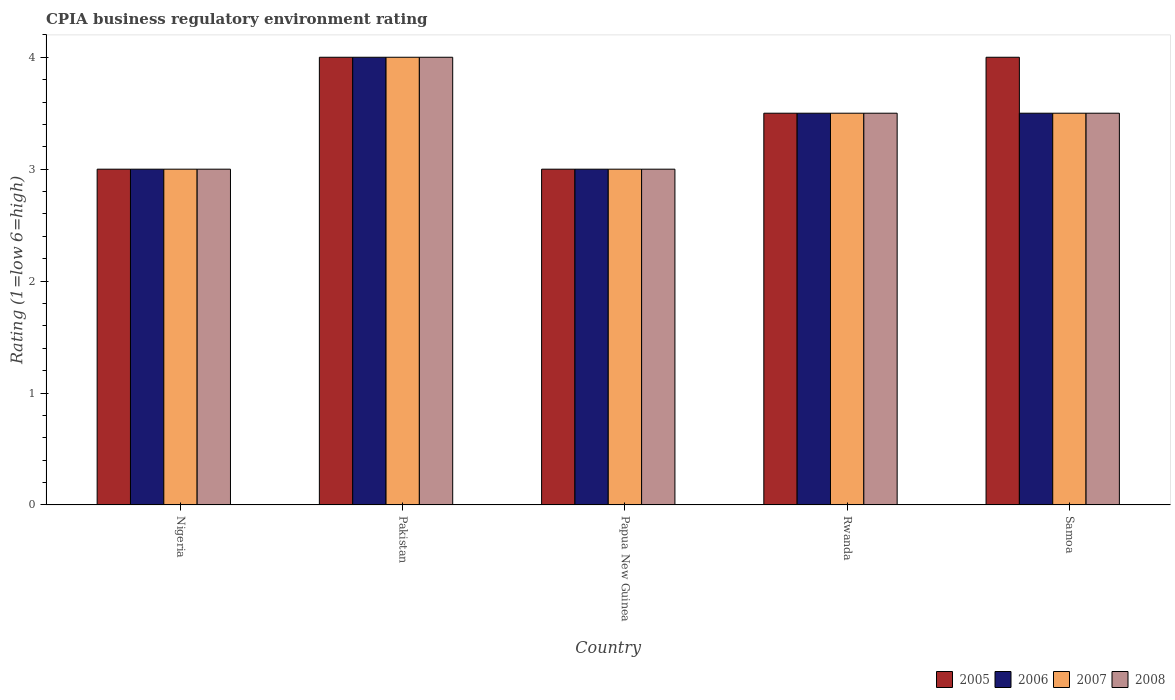How many groups of bars are there?
Keep it short and to the point. 5. Are the number of bars on each tick of the X-axis equal?
Offer a terse response. Yes. What is the label of the 4th group of bars from the left?
Your response must be concise. Rwanda. In how many cases, is the number of bars for a given country not equal to the number of legend labels?
Give a very brief answer. 0. What is the CPIA rating in 2007 in Nigeria?
Give a very brief answer. 3. Across all countries, what is the maximum CPIA rating in 2008?
Your answer should be very brief. 4. In which country was the CPIA rating in 2008 maximum?
Your answer should be very brief. Pakistan. In which country was the CPIA rating in 2008 minimum?
Make the answer very short. Nigeria. What is the total CPIA rating in 2008 in the graph?
Your response must be concise. 17. What is the difference between the CPIA rating in 2006 in Rwanda and the CPIA rating in 2008 in Papua New Guinea?
Offer a very short reply. 0.5. What is the average CPIA rating in 2005 per country?
Provide a succinct answer. 3.5. In how many countries, is the CPIA rating in 2008 greater than 1?
Your answer should be compact. 5. What is the ratio of the CPIA rating in 2008 in Papua New Guinea to that in Rwanda?
Your response must be concise. 0.86. In how many countries, is the CPIA rating in 2007 greater than the average CPIA rating in 2007 taken over all countries?
Provide a short and direct response. 3. What does the 3rd bar from the left in Samoa represents?
Provide a succinct answer. 2007. What does the 1st bar from the right in Rwanda represents?
Make the answer very short. 2008. How many bars are there?
Ensure brevity in your answer.  20. Are all the bars in the graph horizontal?
Give a very brief answer. No. Are the values on the major ticks of Y-axis written in scientific E-notation?
Offer a terse response. No. Does the graph contain any zero values?
Give a very brief answer. No. Does the graph contain grids?
Make the answer very short. No. What is the title of the graph?
Your answer should be very brief. CPIA business regulatory environment rating. Does "1988" appear as one of the legend labels in the graph?
Your answer should be very brief. No. What is the Rating (1=low 6=high) in 2006 in Nigeria?
Offer a terse response. 3. What is the Rating (1=low 6=high) in 2008 in Nigeria?
Give a very brief answer. 3. What is the Rating (1=low 6=high) in 2006 in Pakistan?
Your answer should be very brief. 4. What is the Rating (1=low 6=high) of 2007 in Pakistan?
Keep it short and to the point. 4. What is the Rating (1=low 6=high) of 2005 in Papua New Guinea?
Keep it short and to the point. 3. What is the Rating (1=low 6=high) in 2005 in Rwanda?
Your response must be concise. 3.5. What is the Rating (1=low 6=high) in 2007 in Rwanda?
Your answer should be compact. 3.5. What is the Rating (1=low 6=high) in 2008 in Rwanda?
Make the answer very short. 3.5. What is the Rating (1=low 6=high) in 2005 in Samoa?
Your answer should be compact. 4. What is the Rating (1=low 6=high) in 2008 in Samoa?
Offer a very short reply. 3.5. Across all countries, what is the maximum Rating (1=low 6=high) of 2005?
Offer a terse response. 4. Across all countries, what is the minimum Rating (1=low 6=high) in 2005?
Provide a short and direct response. 3. Across all countries, what is the minimum Rating (1=low 6=high) of 2006?
Give a very brief answer. 3. Across all countries, what is the minimum Rating (1=low 6=high) of 2008?
Keep it short and to the point. 3. What is the total Rating (1=low 6=high) of 2005 in the graph?
Your response must be concise. 17.5. What is the difference between the Rating (1=low 6=high) of 2007 in Nigeria and that in Pakistan?
Your response must be concise. -1. What is the difference between the Rating (1=low 6=high) in 2008 in Nigeria and that in Pakistan?
Keep it short and to the point. -1. What is the difference between the Rating (1=low 6=high) in 2006 in Nigeria and that in Papua New Guinea?
Provide a short and direct response. 0. What is the difference between the Rating (1=low 6=high) in 2007 in Nigeria and that in Papua New Guinea?
Your response must be concise. 0. What is the difference between the Rating (1=low 6=high) of 2005 in Nigeria and that in Rwanda?
Your answer should be compact. -0.5. What is the difference between the Rating (1=low 6=high) in 2007 in Nigeria and that in Rwanda?
Give a very brief answer. -0.5. What is the difference between the Rating (1=low 6=high) in 2008 in Nigeria and that in Rwanda?
Ensure brevity in your answer.  -0.5. What is the difference between the Rating (1=low 6=high) in 2005 in Nigeria and that in Samoa?
Your answer should be very brief. -1. What is the difference between the Rating (1=low 6=high) of 2007 in Nigeria and that in Samoa?
Provide a short and direct response. -0.5. What is the difference between the Rating (1=low 6=high) of 2008 in Nigeria and that in Samoa?
Your answer should be very brief. -0.5. What is the difference between the Rating (1=low 6=high) of 2005 in Pakistan and that in Papua New Guinea?
Your response must be concise. 1. What is the difference between the Rating (1=low 6=high) of 2006 in Pakistan and that in Papua New Guinea?
Offer a terse response. 1. What is the difference between the Rating (1=low 6=high) in 2008 in Pakistan and that in Papua New Guinea?
Provide a short and direct response. 1. What is the difference between the Rating (1=low 6=high) of 2006 in Pakistan and that in Rwanda?
Your answer should be very brief. 0.5. What is the difference between the Rating (1=low 6=high) of 2007 in Pakistan and that in Rwanda?
Give a very brief answer. 0.5. What is the difference between the Rating (1=low 6=high) in 2006 in Pakistan and that in Samoa?
Keep it short and to the point. 0.5. What is the difference between the Rating (1=low 6=high) in 2008 in Pakistan and that in Samoa?
Ensure brevity in your answer.  0.5. What is the difference between the Rating (1=low 6=high) in 2005 in Papua New Guinea and that in Rwanda?
Your answer should be very brief. -0.5. What is the difference between the Rating (1=low 6=high) of 2006 in Papua New Guinea and that in Rwanda?
Provide a short and direct response. -0.5. What is the difference between the Rating (1=low 6=high) of 2007 in Papua New Guinea and that in Rwanda?
Provide a short and direct response. -0.5. What is the difference between the Rating (1=low 6=high) in 2005 in Papua New Guinea and that in Samoa?
Provide a succinct answer. -1. What is the difference between the Rating (1=low 6=high) in 2008 in Papua New Guinea and that in Samoa?
Ensure brevity in your answer.  -0.5. What is the difference between the Rating (1=low 6=high) of 2006 in Rwanda and that in Samoa?
Offer a very short reply. 0. What is the difference between the Rating (1=low 6=high) in 2007 in Rwanda and that in Samoa?
Make the answer very short. 0. What is the difference between the Rating (1=low 6=high) in 2008 in Rwanda and that in Samoa?
Your answer should be very brief. 0. What is the difference between the Rating (1=low 6=high) in 2005 in Nigeria and the Rating (1=low 6=high) in 2006 in Pakistan?
Offer a terse response. -1. What is the difference between the Rating (1=low 6=high) of 2005 in Nigeria and the Rating (1=low 6=high) of 2007 in Pakistan?
Your answer should be very brief. -1. What is the difference between the Rating (1=low 6=high) of 2005 in Nigeria and the Rating (1=low 6=high) of 2008 in Pakistan?
Provide a short and direct response. -1. What is the difference between the Rating (1=low 6=high) in 2005 in Nigeria and the Rating (1=low 6=high) in 2006 in Papua New Guinea?
Provide a succinct answer. 0. What is the difference between the Rating (1=low 6=high) of 2005 in Nigeria and the Rating (1=low 6=high) of 2008 in Papua New Guinea?
Your response must be concise. 0. What is the difference between the Rating (1=low 6=high) in 2006 in Nigeria and the Rating (1=low 6=high) in 2007 in Papua New Guinea?
Offer a very short reply. 0. What is the difference between the Rating (1=low 6=high) in 2006 in Nigeria and the Rating (1=low 6=high) in 2008 in Papua New Guinea?
Make the answer very short. 0. What is the difference between the Rating (1=low 6=high) in 2007 in Nigeria and the Rating (1=low 6=high) in 2008 in Papua New Guinea?
Keep it short and to the point. 0. What is the difference between the Rating (1=low 6=high) of 2005 in Nigeria and the Rating (1=low 6=high) of 2006 in Rwanda?
Provide a short and direct response. -0.5. What is the difference between the Rating (1=low 6=high) of 2005 in Nigeria and the Rating (1=low 6=high) of 2008 in Rwanda?
Offer a terse response. -0.5. What is the difference between the Rating (1=low 6=high) of 2006 in Nigeria and the Rating (1=low 6=high) of 2008 in Rwanda?
Make the answer very short. -0.5. What is the difference between the Rating (1=low 6=high) in 2007 in Nigeria and the Rating (1=low 6=high) in 2008 in Rwanda?
Give a very brief answer. -0.5. What is the difference between the Rating (1=low 6=high) in 2005 in Nigeria and the Rating (1=low 6=high) in 2006 in Samoa?
Make the answer very short. -0.5. What is the difference between the Rating (1=low 6=high) in 2005 in Nigeria and the Rating (1=low 6=high) in 2007 in Samoa?
Offer a terse response. -0.5. What is the difference between the Rating (1=low 6=high) in 2005 in Nigeria and the Rating (1=low 6=high) in 2008 in Samoa?
Offer a very short reply. -0.5. What is the difference between the Rating (1=low 6=high) of 2007 in Nigeria and the Rating (1=low 6=high) of 2008 in Samoa?
Offer a terse response. -0.5. What is the difference between the Rating (1=low 6=high) in 2005 in Pakistan and the Rating (1=low 6=high) in 2006 in Papua New Guinea?
Give a very brief answer. 1. What is the difference between the Rating (1=low 6=high) of 2006 in Pakistan and the Rating (1=low 6=high) of 2008 in Papua New Guinea?
Give a very brief answer. 1. What is the difference between the Rating (1=low 6=high) of 2007 in Pakistan and the Rating (1=low 6=high) of 2008 in Papua New Guinea?
Your response must be concise. 1. What is the difference between the Rating (1=low 6=high) in 2005 in Pakistan and the Rating (1=low 6=high) in 2006 in Rwanda?
Your response must be concise. 0.5. What is the difference between the Rating (1=low 6=high) in 2005 in Pakistan and the Rating (1=low 6=high) in 2008 in Rwanda?
Offer a very short reply. 0.5. What is the difference between the Rating (1=low 6=high) of 2005 in Pakistan and the Rating (1=low 6=high) of 2007 in Samoa?
Offer a terse response. 0.5. What is the difference between the Rating (1=low 6=high) of 2006 in Papua New Guinea and the Rating (1=low 6=high) of 2007 in Rwanda?
Give a very brief answer. -0.5. What is the difference between the Rating (1=low 6=high) in 2007 in Papua New Guinea and the Rating (1=low 6=high) in 2008 in Rwanda?
Make the answer very short. -0.5. What is the difference between the Rating (1=low 6=high) in 2005 in Papua New Guinea and the Rating (1=low 6=high) in 2008 in Samoa?
Keep it short and to the point. -0.5. What is the difference between the Rating (1=low 6=high) of 2006 in Papua New Guinea and the Rating (1=low 6=high) of 2007 in Samoa?
Provide a short and direct response. -0.5. What is the difference between the Rating (1=low 6=high) of 2006 in Papua New Guinea and the Rating (1=low 6=high) of 2008 in Samoa?
Your response must be concise. -0.5. What is the difference between the Rating (1=low 6=high) in 2006 in Rwanda and the Rating (1=low 6=high) in 2007 in Samoa?
Keep it short and to the point. 0. What is the difference between the Rating (1=low 6=high) in 2006 in Rwanda and the Rating (1=low 6=high) in 2008 in Samoa?
Provide a short and direct response. 0. What is the difference between the Rating (1=low 6=high) in 2007 in Rwanda and the Rating (1=low 6=high) in 2008 in Samoa?
Provide a succinct answer. 0. What is the average Rating (1=low 6=high) in 2006 per country?
Offer a very short reply. 3.4. What is the average Rating (1=low 6=high) of 2008 per country?
Provide a short and direct response. 3.4. What is the difference between the Rating (1=low 6=high) in 2005 and Rating (1=low 6=high) in 2006 in Nigeria?
Provide a succinct answer. 0. What is the difference between the Rating (1=low 6=high) of 2005 and Rating (1=low 6=high) of 2008 in Nigeria?
Provide a short and direct response. 0. What is the difference between the Rating (1=low 6=high) of 2006 and Rating (1=low 6=high) of 2008 in Nigeria?
Offer a very short reply. 0. What is the difference between the Rating (1=low 6=high) of 2007 and Rating (1=low 6=high) of 2008 in Nigeria?
Your answer should be compact. 0. What is the difference between the Rating (1=low 6=high) in 2005 and Rating (1=low 6=high) in 2007 in Pakistan?
Your answer should be very brief. 0. What is the difference between the Rating (1=low 6=high) of 2005 and Rating (1=low 6=high) of 2008 in Pakistan?
Provide a succinct answer. 0. What is the difference between the Rating (1=low 6=high) of 2006 and Rating (1=low 6=high) of 2007 in Pakistan?
Offer a very short reply. 0. What is the difference between the Rating (1=low 6=high) in 2007 and Rating (1=low 6=high) in 2008 in Pakistan?
Provide a succinct answer. 0. What is the difference between the Rating (1=low 6=high) of 2005 and Rating (1=low 6=high) of 2007 in Papua New Guinea?
Your answer should be very brief. 0. What is the difference between the Rating (1=low 6=high) in 2006 and Rating (1=low 6=high) in 2007 in Papua New Guinea?
Ensure brevity in your answer.  0. What is the difference between the Rating (1=low 6=high) of 2006 and Rating (1=low 6=high) of 2008 in Papua New Guinea?
Provide a short and direct response. 0. What is the difference between the Rating (1=low 6=high) of 2005 and Rating (1=low 6=high) of 2008 in Rwanda?
Offer a very short reply. 0. What is the difference between the Rating (1=low 6=high) of 2007 and Rating (1=low 6=high) of 2008 in Rwanda?
Offer a terse response. 0. What is the difference between the Rating (1=low 6=high) of 2005 and Rating (1=low 6=high) of 2008 in Samoa?
Provide a succinct answer. 0.5. What is the difference between the Rating (1=low 6=high) of 2006 and Rating (1=low 6=high) of 2007 in Samoa?
Ensure brevity in your answer.  0. What is the difference between the Rating (1=low 6=high) in 2007 and Rating (1=low 6=high) in 2008 in Samoa?
Your response must be concise. 0. What is the ratio of the Rating (1=low 6=high) of 2007 in Nigeria to that in Pakistan?
Your answer should be compact. 0.75. What is the ratio of the Rating (1=low 6=high) in 2006 in Nigeria to that in Papua New Guinea?
Your answer should be very brief. 1. What is the ratio of the Rating (1=low 6=high) of 2008 in Nigeria to that in Papua New Guinea?
Keep it short and to the point. 1. What is the ratio of the Rating (1=low 6=high) in 2006 in Nigeria to that in Rwanda?
Provide a short and direct response. 0.86. What is the ratio of the Rating (1=low 6=high) of 2008 in Nigeria to that in Rwanda?
Keep it short and to the point. 0.86. What is the ratio of the Rating (1=low 6=high) in 2005 in Nigeria to that in Samoa?
Provide a short and direct response. 0.75. What is the ratio of the Rating (1=low 6=high) of 2006 in Nigeria to that in Samoa?
Give a very brief answer. 0.86. What is the ratio of the Rating (1=low 6=high) in 2007 in Nigeria to that in Samoa?
Offer a very short reply. 0.86. What is the ratio of the Rating (1=low 6=high) in 2008 in Nigeria to that in Samoa?
Ensure brevity in your answer.  0.86. What is the ratio of the Rating (1=low 6=high) of 2005 in Pakistan to that in Papua New Guinea?
Your answer should be very brief. 1.33. What is the ratio of the Rating (1=low 6=high) of 2006 in Pakistan to that in Papua New Guinea?
Make the answer very short. 1.33. What is the ratio of the Rating (1=low 6=high) of 2005 in Pakistan to that in Rwanda?
Keep it short and to the point. 1.14. What is the ratio of the Rating (1=low 6=high) in 2008 in Pakistan to that in Rwanda?
Your response must be concise. 1.14. What is the ratio of the Rating (1=low 6=high) in 2005 in Pakistan to that in Samoa?
Provide a short and direct response. 1. What is the ratio of the Rating (1=low 6=high) of 2006 in Papua New Guinea to that in Rwanda?
Your answer should be very brief. 0.86. What is the ratio of the Rating (1=low 6=high) of 2007 in Papua New Guinea to that in Rwanda?
Keep it short and to the point. 0.86. What is the ratio of the Rating (1=low 6=high) of 2005 in Papua New Guinea to that in Samoa?
Offer a terse response. 0.75. What is the ratio of the Rating (1=low 6=high) of 2006 in Papua New Guinea to that in Samoa?
Your answer should be very brief. 0.86. What is the ratio of the Rating (1=low 6=high) in 2007 in Papua New Guinea to that in Samoa?
Provide a short and direct response. 0.86. What is the ratio of the Rating (1=low 6=high) in 2008 in Papua New Guinea to that in Samoa?
Your response must be concise. 0.86. What is the ratio of the Rating (1=low 6=high) in 2005 in Rwanda to that in Samoa?
Offer a terse response. 0.88. What is the ratio of the Rating (1=low 6=high) of 2008 in Rwanda to that in Samoa?
Your answer should be very brief. 1. What is the difference between the highest and the second highest Rating (1=low 6=high) in 2007?
Give a very brief answer. 0.5. What is the difference between the highest and the second highest Rating (1=low 6=high) of 2008?
Your answer should be very brief. 0.5. What is the difference between the highest and the lowest Rating (1=low 6=high) in 2007?
Give a very brief answer. 1. What is the difference between the highest and the lowest Rating (1=low 6=high) of 2008?
Make the answer very short. 1. 